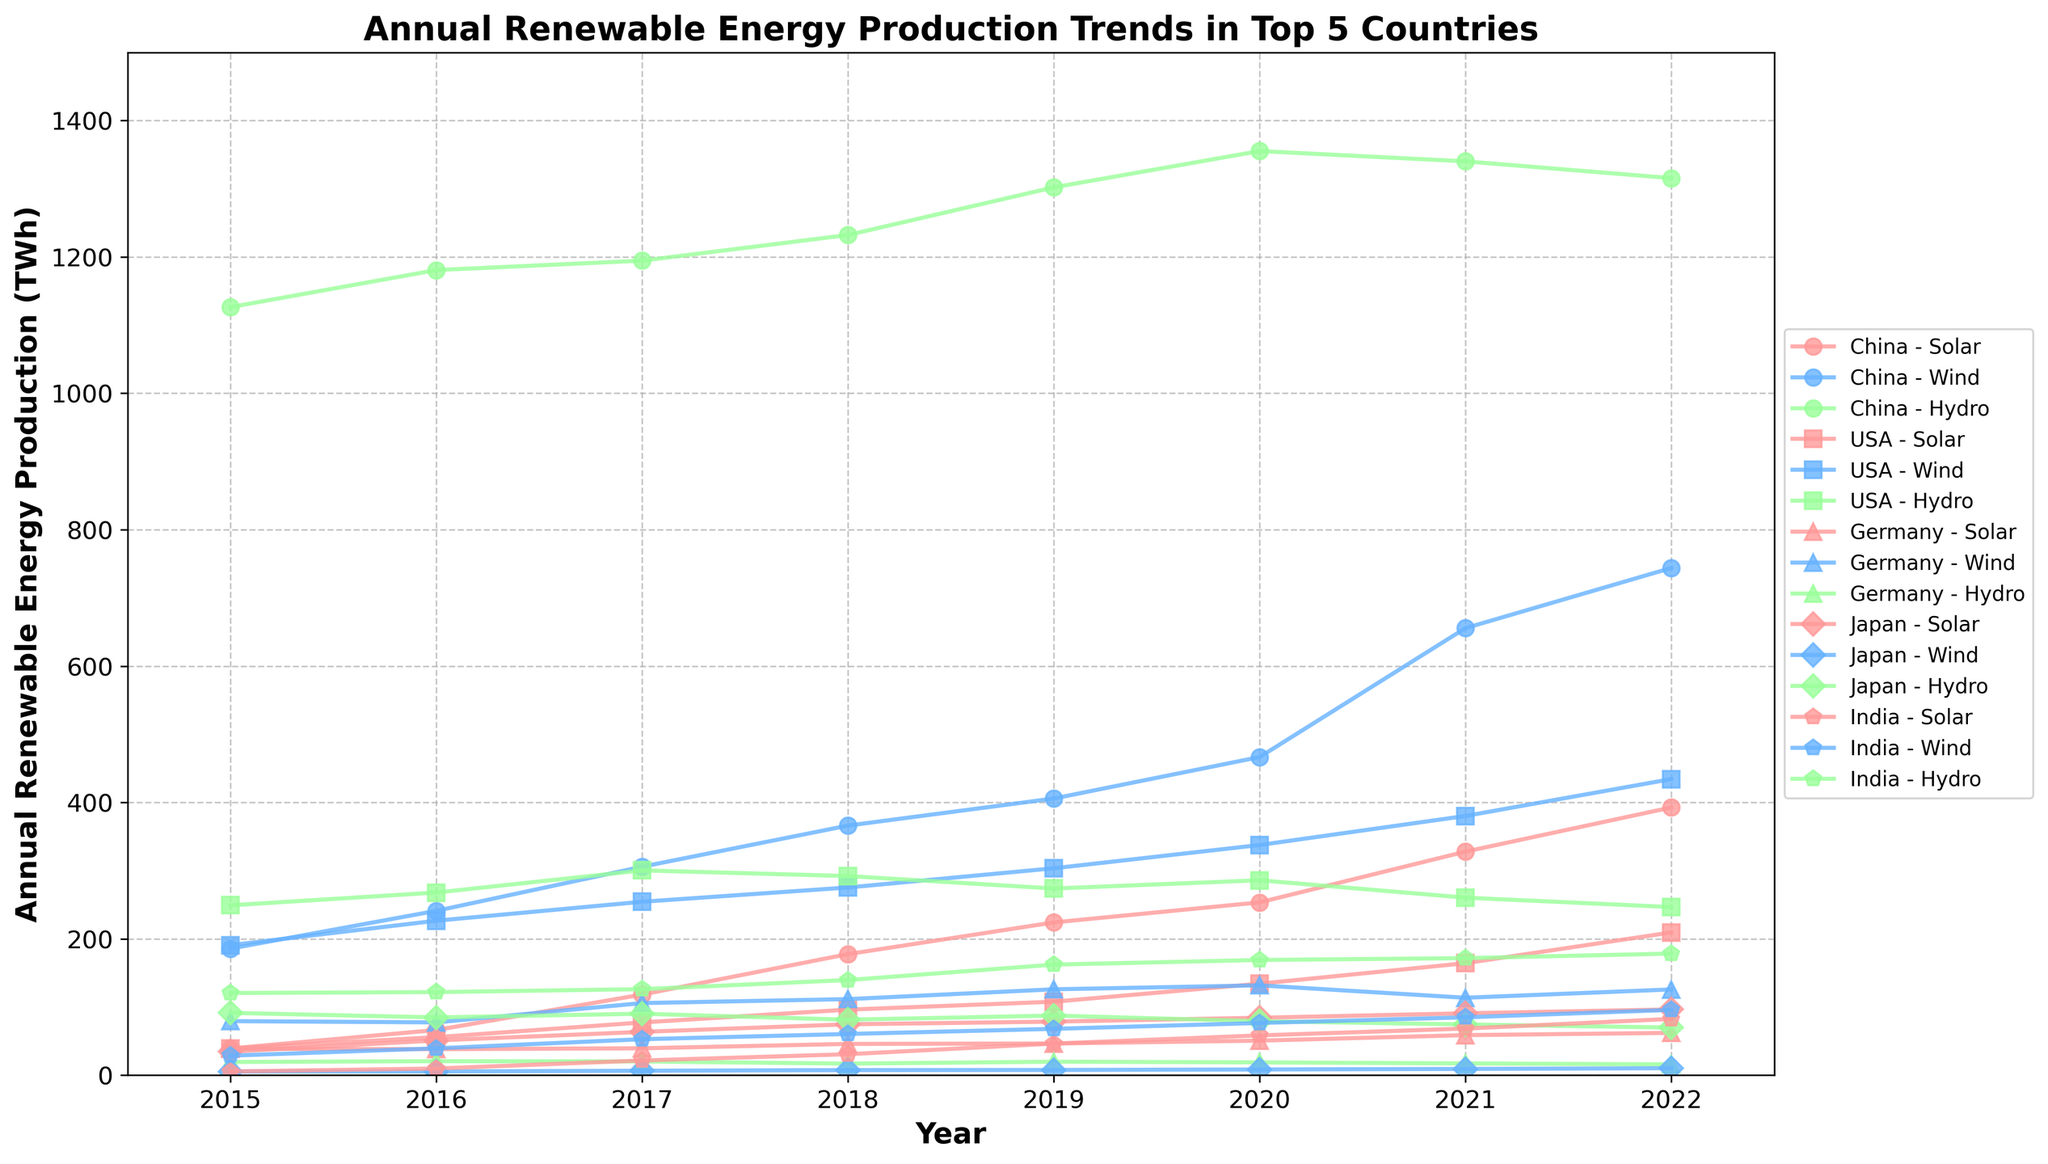What was the trend for USA Solar production from 2015 to 2022? To find the trend for USA Solar production, look at its plotted line in the figure. It's clear that USA Solar production increased from 39.0 TWh in 2015 to 209.3 TWh in 2022.
Answer: Increasing In 2020, which energy type had the highest annual production in China? In 2020, check the height of the lines for all energy types in China. The Hydro production line is the highest with 1355.2 TWh.
Answer: Hydro Which country saw the largest increase in Wind energy production from 2015 to 2022? To determine this, compare the starting and ending points of the Wind energy lines for all countries. China went from 185.6 TWh to 743.8 TWh, the largest increase.
Answer: China How did Japan's Solar production in 2020 compare to India's Solar production in the same year? Look at the lines for both Japan and India's Solar production in 2020. Japan produced 84.2 TWh while India produced 58.3 TWh.
Answer: Japan produced more By how much did Germany's Wind energy production increase from 2015 to 2022? Look at the values for Germany Wind in 2015 and 2022. The increase is 125.7 TWh - 79.2 TWh = 46.5 TWh.
Answer: 46.5 TWh In 2022, which country had the lowest Hydro energy production? Check the values for Hydro energy for all countries in 2022. Germany had the lowest Hydro energy production with 15.8 TWh.
Answer: Germany What is the average annual production of Solar energy in India from 2015 to 2022? Sum the annual Solar production values for India from 2015 to 2022 and divide by the number of years (8). (5.5 + 9.7 + 21.5 + 30.7 + 46.3 + 58.3 + 68.3 + 82.5) / 8 = 40.48 TWh.
Answer: 40.48 TWh Which country's renewable energy production was the most consistent over the years across all types? Look at the overall trends for all three energy types for each country and check the steady lines. China's Hydro production was the most consistent as it showed the smallest increase, indicating stable production levels.
Answer: China Hydro In 2018, did the USA produce more Wind or Solar energy? Compare the heights of the Wind and Solar production lines for the USA in 2018. USA Wind (275.2 TWh) was higher than USA Solar (96.1 TWh).
Answer: Wind 